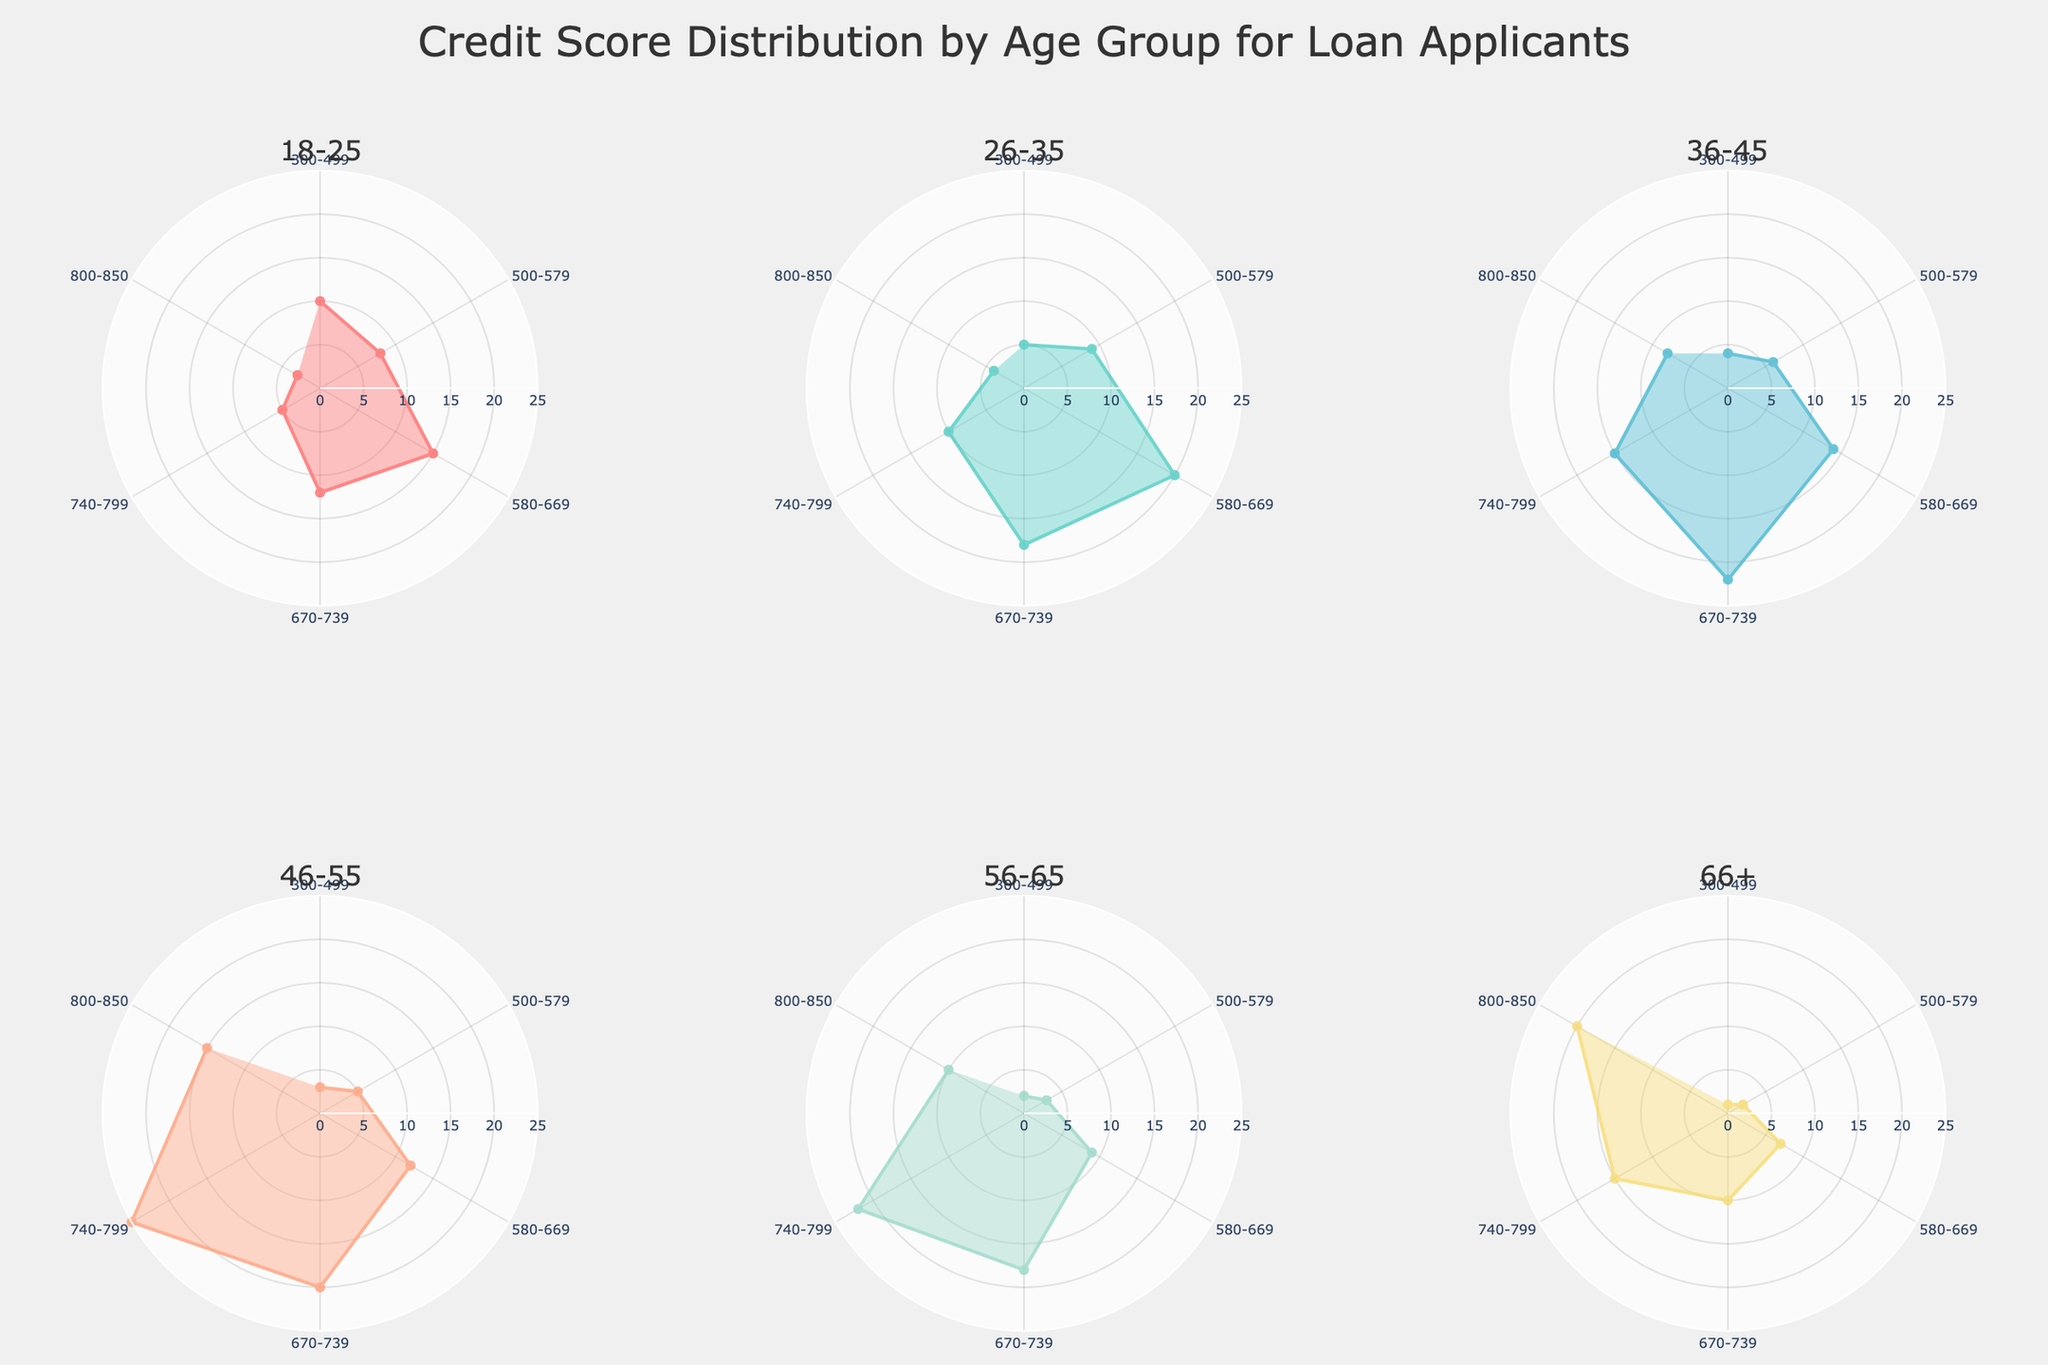What's the title of the figure? The title is placed at the top center of the figure and clearly states what the figure represents.
Answer: Credit Score Distribution by Age Group for Loan Applicants What do the different colors represent in each subplot? Each subplot is shaded with distinct colors to differentiate between the different age groups. Specifically, the different lines and filled areas represent the Loan Applicant Count for each credit score range.
Answer: Different age groups How many credit score range categories are there in the figure? Each subplot has the same number of categories represented by different points on the polar chart. By counting them, we can see there are 6 categories.
Answer: 6 Which age group has the highest number of loan applicants with a credit score of 800-850? By examining the plots, we look at the 800-850 credit score range for each age group and compare the loan applicant counts. The highest count is clearly visible due to the length of the radial line.
Answer: 66+ Which age group has the most balanced credit score distribution? A balanced distribution would have similar lengths of radial lines in all directions. By visual inspection, the age group where the lines are more evenly spread is what we need to identify.
Answer: 26-35 How many loan applicants in the 46-55 age group have a credit score between 740-799 and 800-850 combined? Check the radial lines for the 46-55 age group at the 740-799 and 800-850 positions. The counts for these positions are 25 and 15, respectively. Sum these counts: 25 + 15 = 40.
Answer: 40 What is the average loan applicant count for the 56-65 age group? Calculate the average by summing the counts of each credit score range for the 56-65 age group and then dividing by the number of categories (6). The counts are: 2, 3, 9, 18, 22, 10. Sum = 64. Then, 64/6 ≈ 10.67.
Answer: ~10.67 Which age group has the lowest number of loan applicants with a credit score between 580-669? We need to find the shortest radial line corresponding to the 580-669 credit score range and identify the associated age group.
Answer: 66+ Compare the loan applicant count with a credit score of 670-739 between the 18-25 and 36-45 age groups. Which one is higher? Check the radial lines for both age groups at the 670-739 credit score range. The 36-45 age group has a longer radial line, indicating a higher count.
Answer: 36-45 